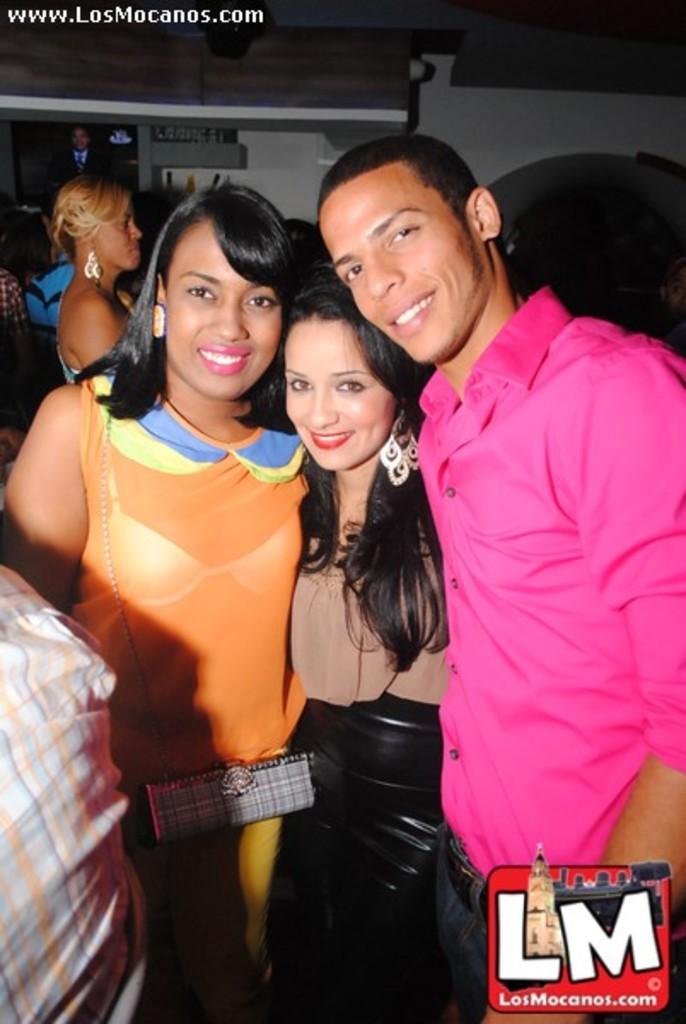Please provide a concise description of this image. In this image I can see in the middle two girls are standing and smiling, on the right side a man is also smiling, he is wearing a shirt. At the bottom there is the logo, in the left hand side top there is the website name. 